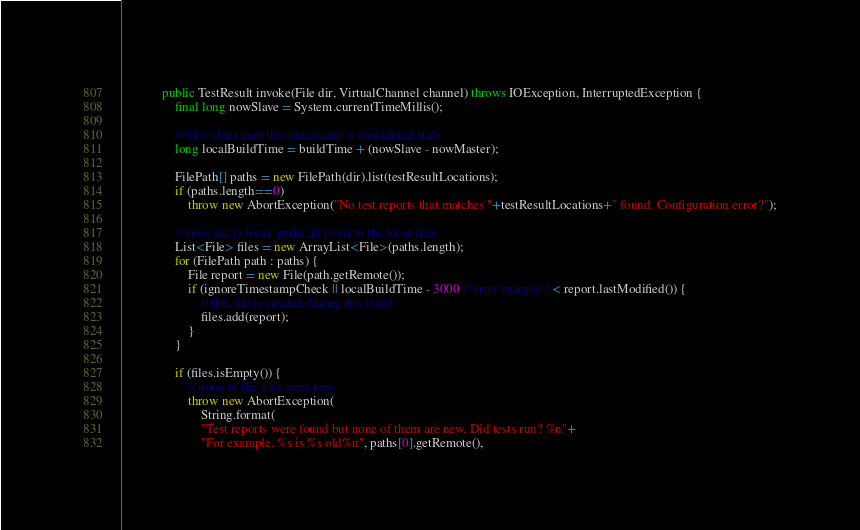<code> <loc_0><loc_0><loc_500><loc_500><_Java_>
            public TestResult invoke(File dir, VirtualChannel channel) throws IOException, InterruptedException {
                final long nowSlave = System.currentTimeMillis();

                // files older than this timestamp is considered stale
                long localBuildTime = buildTime + (nowSlave - nowMaster);

                FilePath[] paths = new FilePath(dir).list(testResultLocations);
                if (paths.length==0)
                    throw new AbortException("No test reports that matches "+testResultLocations+" found. Configuration error?");

                // since dir is local, paths all point to the local files
                List<File> files = new ArrayList<File>(paths.length);
                for (FilePath path : paths) {
                    File report = new File(path.getRemote());
                    if (ignoreTimestampCheck || localBuildTime - 3000 /*error margin*/ < report.lastModified()) {
                        // this file is created during this build
                        files.add(report);
                    }
                }

                if (files.isEmpty()) {
                    // none of the files were new
                    throw new AbortException(
                        String.format(
                        "Test reports were found but none of them are new. Did tests run? %n"+
                        "For example, %s is %s old%n", paths[0].getRemote(),</code> 